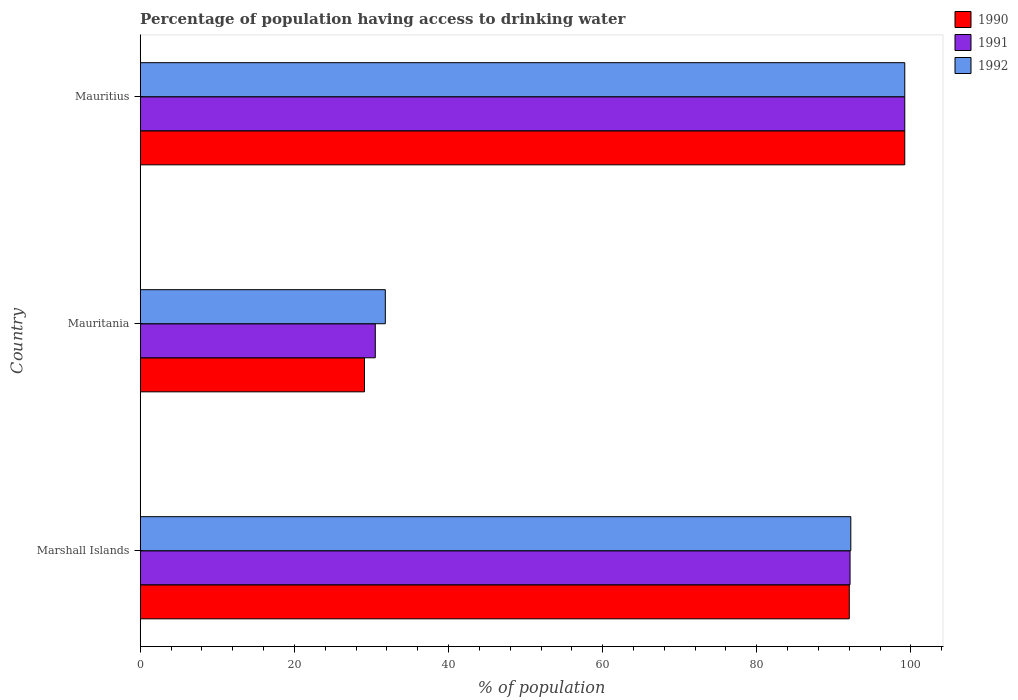How many groups of bars are there?
Your answer should be very brief. 3. What is the label of the 2nd group of bars from the top?
Keep it short and to the point. Mauritania. In how many cases, is the number of bars for a given country not equal to the number of legend labels?
Provide a succinct answer. 0. What is the percentage of population having access to drinking water in 1992 in Mauritania?
Make the answer very short. 31.8. Across all countries, what is the maximum percentage of population having access to drinking water in 1992?
Offer a very short reply. 99.2. Across all countries, what is the minimum percentage of population having access to drinking water in 1992?
Your answer should be compact. 31.8. In which country was the percentage of population having access to drinking water in 1990 maximum?
Your answer should be very brief. Mauritius. In which country was the percentage of population having access to drinking water in 1990 minimum?
Ensure brevity in your answer.  Mauritania. What is the total percentage of population having access to drinking water in 1992 in the graph?
Provide a short and direct response. 223.2. What is the difference between the percentage of population having access to drinking water in 1991 in Marshall Islands and that in Mauritania?
Give a very brief answer. 61.6. What is the difference between the percentage of population having access to drinking water in 1990 in Mauritius and the percentage of population having access to drinking water in 1992 in Mauritania?
Provide a succinct answer. 67.4. What is the average percentage of population having access to drinking water in 1990 per country?
Give a very brief answer. 73.43. What is the difference between the percentage of population having access to drinking water in 1992 and percentage of population having access to drinking water in 1991 in Marshall Islands?
Your answer should be very brief. 0.1. In how many countries, is the percentage of population having access to drinking water in 1992 greater than 36 %?
Ensure brevity in your answer.  2. What is the ratio of the percentage of population having access to drinking water in 1991 in Marshall Islands to that in Mauritania?
Offer a very short reply. 3.02. Is the percentage of population having access to drinking water in 1992 in Marshall Islands less than that in Mauritius?
Your answer should be very brief. Yes. What is the difference between the highest and the second highest percentage of population having access to drinking water in 1991?
Make the answer very short. 7.1. What is the difference between the highest and the lowest percentage of population having access to drinking water in 1990?
Ensure brevity in your answer.  70.1. What does the 3rd bar from the bottom in Mauritania represents?
Make the answer very short. 1992. How many bars are there?
Provide a succinct answer. 9. How many countries are there in the graph?
Ensure brevity in your answer.  3. How many legend labels are there?
Your answer should be very brief. 3. How are the legend labels stacked?
Offer a terse response. Vertical. What is the title of the graph?
Your answer should be very brief. Percentage of population having access to drinking water. Does "2001" appear as one of the legend labels in the graph?
Your answer should be very brief. No. What is the label or title of the X-axis?
Offer a very short reply. % of population. What is the label or title of the Y-axis?
Provide a succinct answer. Country. What is the % of population in 1990 in Marshall Islands?
Offer a very short reply. 92. What is the % of population of 1991 in Marshall Islands?
Keep it short and to the point. 92.1. What is the % of population in 1992 in Marshall Islands?
Provide a succinct answer. 92.2. What is the % of population of 1990 in Mauritania?
Your answer should be compact. 29.1. What is the % of population of 1991 in Mauritania?
Your response must be concise. 30.5. What is the % of population in 1992 in Mauritania?
Your answer should be very brief. 31.8. What is the % of population of 1990 in Mauritius?
Give a very brief answer. 99.2. What is the % of population of 1991 in Mauritius?
Offer a terse response. 99.2. What is the % of population of 1992 in Mauritius?
Provide a short and direct response. 99.2. Across all countries, what is the maximum % of population of 1990?
Ensure brevity in your answer.  99.2. Across all countries, what is the maximum % of population of 1991?
Ensure brevity in your answer.  99.2. Across all countries, what is the maximum % of population in 1992?
Give a very brief answer. 99.2. Across all countries, what is the minimum % of population of 1990?
Keep it short and to the point. 29.1. Across all countries, what is the minimum % of population of 1991?
Provide a succinct answer. 30.5. Across all countries, what is the minimum % of population in 1992?
Provide a succinct answer. 31.8. What is the total % of population of 1990 in the graph?
Provide a short and direct response. 220.3. What is the total % of population in 1991 in the graph?
Your answer should be compact. 221.8. What is the total % of population in 1992 in the graph?
Ensure brevity in your answer.  223.2. What is the difference between the % of population in 1990 in Marshall Islands and that in Mauritania?
Offer a very short reply. 62.9. What is the difference between the % of population of 1991 in Marshall Islands and that in Mauritania?
Make the answer very short. 61.6. What is the difference between the % of population of 1992 in Marshall Islands and that in Mauritania?
Make the answer very short. 60.4. What is the difference between the % of population of 1990 in Marshall Islands and that in Mauritius?
Give a very brief answer. -7.2. What is the difference between the % of population of 1992 in Marshall Islands and that in Mauritius?
Provide a short and direct response. -7. What is the difference between the % of population of 1990 in Mauritania and that in Mauritius?
Offer a terse response. -70.1. What is the difference between the % of population in 1991 in Mauritania and that in Mauritius?
Offer a very short reply. -68.7. What is the difference between the % of population in 1992 in Mauritania and that in Mauritius?
Provide a short and direct response. -67.4. What is the difference between the % of population of 1990 in Marshall Islands and the % of population of 1991 in Mauritania?
Provide a short and direct response. 61.5. What is the difference between the % of population of 1990 in Marshall Islands and the % of population of 1992 in Mauritania?
Your response must be concise. 60.2. What is the difference between the % of population in 1991 in Marshall Islands and the % of population in 1992 in Mauritania?
Keep it short and to the point. 60.3. What is the difference between the % of population of 1990 in Marshall Islands and the % of population of 1991 in Mauritius?
Give a very brief answer. -7.2. What is the difference between the % of population in 1990 in Marshall Islands and the % of population in 1992 in Mauritius?
Your answer should be compact. -7.2. What is the difference between the % of population in 1990 in Mauritania and the % of population in 1991 in Mauritius?
Your response must be concise. -70.1. What is the difference between the % of population in 1990 in Mauritania and the % of population in 1992 in Mauritius?
Keep it short and to the point. -70.1. What is the difference between the % of population in 1991 in Mauritania and the % of population in 1992 in Mauritius?
Offer a very short reply. -68.7. What is the average % of population in 1990 per country?
Offer a very short reply. 73.43. What is the average % of population in 1991 per country?
Your response must be concise. 73.93. What is the average % of population in 1992 per country?
Offer a very short reply. 74.4. What is the difference between the % of population in 1991 and % of population in 1992 in Marshall Islands?
Give a very brief answer. -0.1. What is the difference between the % of population of 1990 and % of population of 1991 in Mauritania?
Provide a succinct answer. -1.4. What is the difference between the % of population of 1990 and % of population of 1992 in Mauritania?
Provide a short and direct response. -2.7. What is the difference between the % of population of 1991 and % of population of 1992 in Mauritania?
Your response must be concise. -1.3. What is the difference between the % of population of 1990 and % of population of 1992 in Mauritius?
Your answer should be compact. 0. What is the ratio of the % of population in 1990 in Marshall Islands to that in Mauritania?
Offer a very short reply. 3.16. What is the ratio of the % of population in 1991 in Marshall Islands to that in Mauritania?
Offer a terse response. 3.02. What is the ratio of the % of population of 1992 in Marshall Islands to that in Mauritania?
Give a very brief answer. 2.9. What is the ratio of the % of population in 1990 in Marshall Islands to that in Mauritius?
Give a very brief answer. 0.93. What is the ratio of the % of population in 1991 in Marshall Islands to that in Mauritius?
Make the answer very short. 0.93. What is the ratio of the % of population of 1992 in Marshall Islands to that in Mauritius?
Your answer should be compact. 0.93. What is the ratio of the % of population in 1990 in Mauritania to that in Mauritius?
Provide a succinct answer. 0.29. What is the ratio of the % of population of 1991 in Mauritania to that in Mauritius?
Your answer should be very brief. 0.31. What is the ratio of the % of population of 1992 in Mauritania to that in Mauritius?
Provide a succinct answer. 0.32. What is the difference between the highest and the second highest % of population of 1990?
Make the answer very short. 7.2. What is the difference between the highest and the lowest % of population of 1990?
Provide a succinct answer. 70.1. What is the difference between the highest and the lowest % of population in 1991?
Provide a short and direct response. 68.7. What is the difference between the highest and the lowest % of population in 1992?
Your answer should be compact. 67.4. 